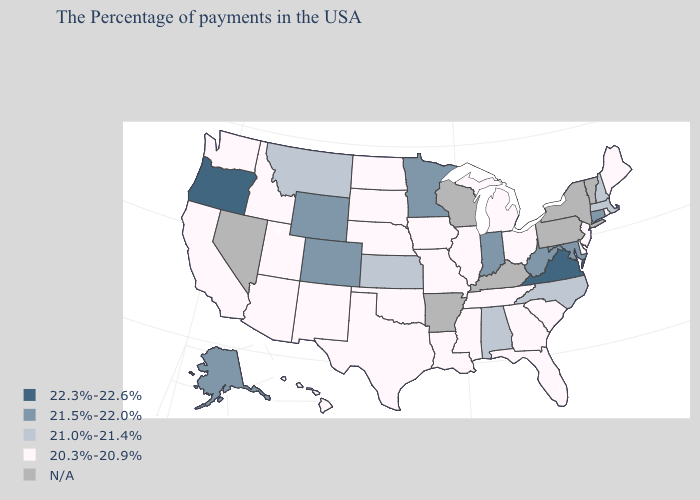Name the states that have a value in the range 22.3%-22.6%?
Write a very short answer. Virginia, Oregon. Which states have the highest value in the USA?
Write a very short answer. Virginia, Oregon. Name the states that have a value in the range 21.5%-22.0%?
Quick response, please. Connecticut, Maryland, West Virginia, Indiana, Minnesota, Wyoming, Colorado, Alaska. Among the states that border Georgia , which have the lowest value?
Concise answer only. South Carolina, Florida, Tennessee. How many symbols are there in the legend?
Give a very brief answer. 5. What is the value of Maryland?
Short answer required. 21.5%-22.0%. Among the states that border South Carolina , does North Carolina have the highest value?
Short answer required. Yes. What is the value of Wyoming?
Answer briefly. 21.5%-22.0%. Name the states that have a value in the range 21.0%-21.4%?
Give a very brief answer. Massachusetts, New Hampshire, North Carolina, Alabama, Kansas, Montana. Which states have the highest value in the USA?
Keep it brief. Virginia, Oregon. What is the value of Iowa?
Be succinct. 20.3%-20.9%. What is the value of Rhode Island?
Short answer required. 20.3%-20.9%. Name the states that have a value in the range 21.0%-21.4%?
Concise answer only. Massachusetts, New Hampshire, North Carolina, Alabama, Kansas, Montana. What is the value of Utah?
Concise answer only. 20.3%-20.9%. 